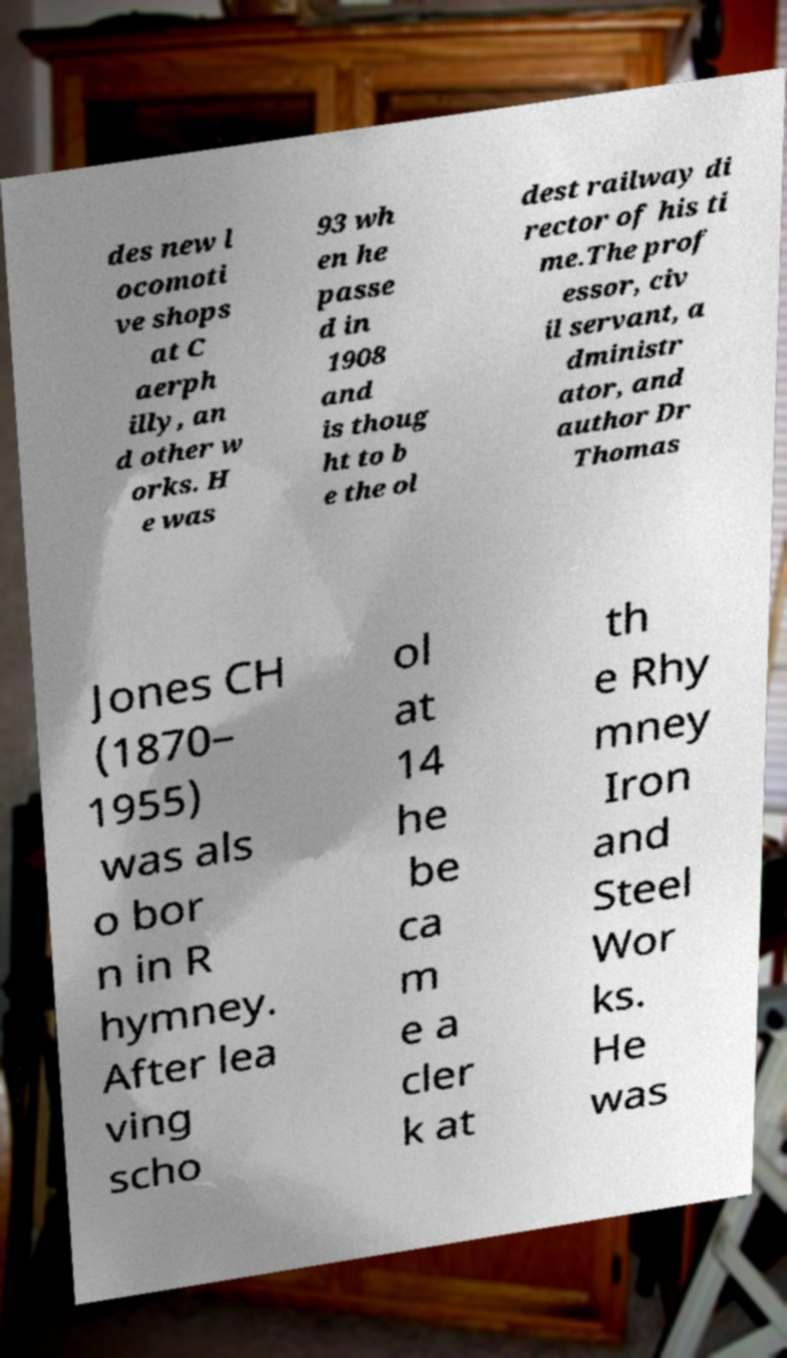I need the written content from this picture converted into text. Can you do that? des new l ocomoti ve shops at C aerph illy, an d other w orks. H e was 93 wh en he passe d in 1908 and is thoug ht to b e the ol dest railway di rector of his ti me.The prof essor, civ il servant, a dministr ator, and author Dr Thomas Jones CH (1870– 1955) was als o bor n in R hymney. After lea ving scho ol at 14 he be ca m e a cler k at th e Rhy mney Iron and Steel Wor ks. He was 